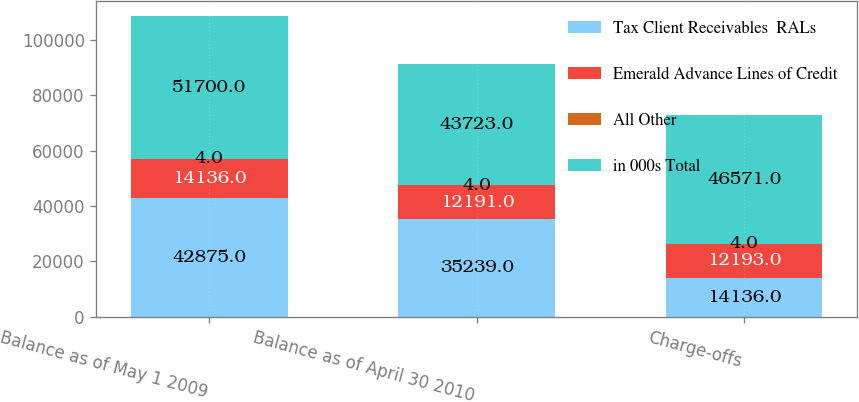Convert chart. <chart><loc_0><loc_0><loc_500><loc_500><stacked_bar_chart><ecel><fcel>Balance as of May 1 2009<fcel>Balance as of April 30 2010<fcel>Charge-offs<nl><fcel>Tax Client Receivables  RALs<fcel>42875<fcel>35239<fcel>14136<nl><fcel>Emerald Advance Lines of Credit<fcel>14136<fcel>12191<fcel>12193<nl><fcel>All Other<fcel>4<fcel>4<fcel>4<nl><fcel>in 000s Total<fcel>51700<fcel>43723<fcel>46571<nl></chart> 